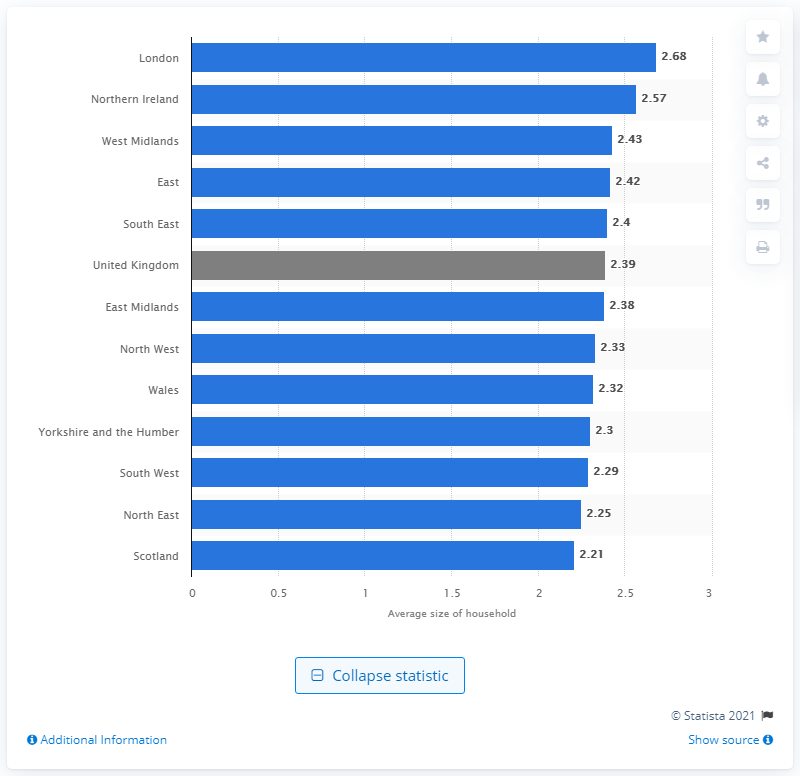Mention a couple of crucial points in this snapshot. Northern Ireland had the second highest average household size among the English regions in 2011. In 2020, the average household size in the UK was 2.39. In 2020, the average household size in London was 2.68. 